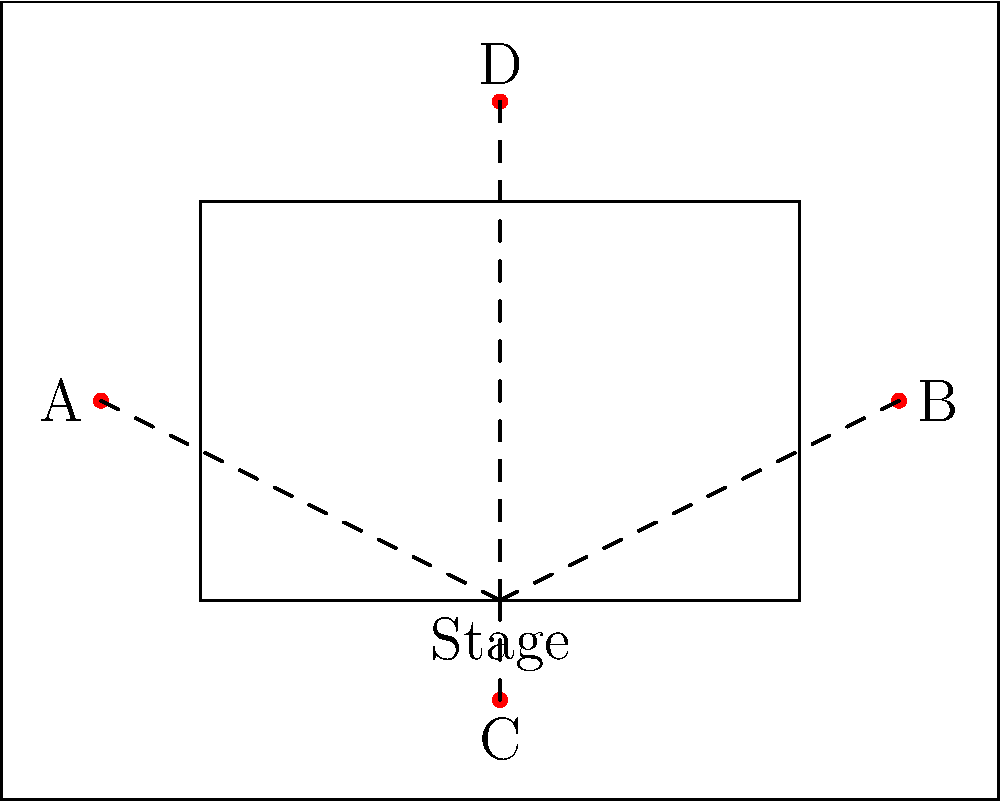Given the layout of a rectangular festival venue with a central stage, four potential speaker positions (A, B, C, D) are marked. Which speaker placement would provide the most balanced sound coverage for the audience? To determine the optimal speaker placement for balanced sound coverage, we need to consider the following factors:

1. Distance from the stage: Speakers should be placed at similar distances from the stage to ensure consistent sound quality.

2. Coverage area: Speakers should be positioned to cover the maximum audience area without leaving significant gaps.

3. Symmetry: A symmetrical layout often provides more balanced sound distribution.

4. Interference: Avoid placing speakers too close to each other to minimize interference.

Analyzing the given options:

A and B:
- Placed symmetrically on either side of the stage
- Cover the widest area of the venue
- Equal distance from the stage

C:
- Placed directly in front of the stage
- Covers only the front area of the venue
- Closest to the stage, which may cause issues with sound balance

D:
- Placed behind the stage
- Covers only the back area of the venue
- May cause confusion for the audience due to sound coming from behind the performers

Considering these factors, the most balanced sound coverage would be achieved by using speakers A and B. They provide:

1. Symmetrical placement
2. Wide coverage area
3. Equal distance from the stage
4. Minimal interference with each other

This setup is commonly known as a stereo pair configuration and is widely used in festival and concert settings to provide balanced, immersive sound to the audience.
Answer: Speakers A and B 